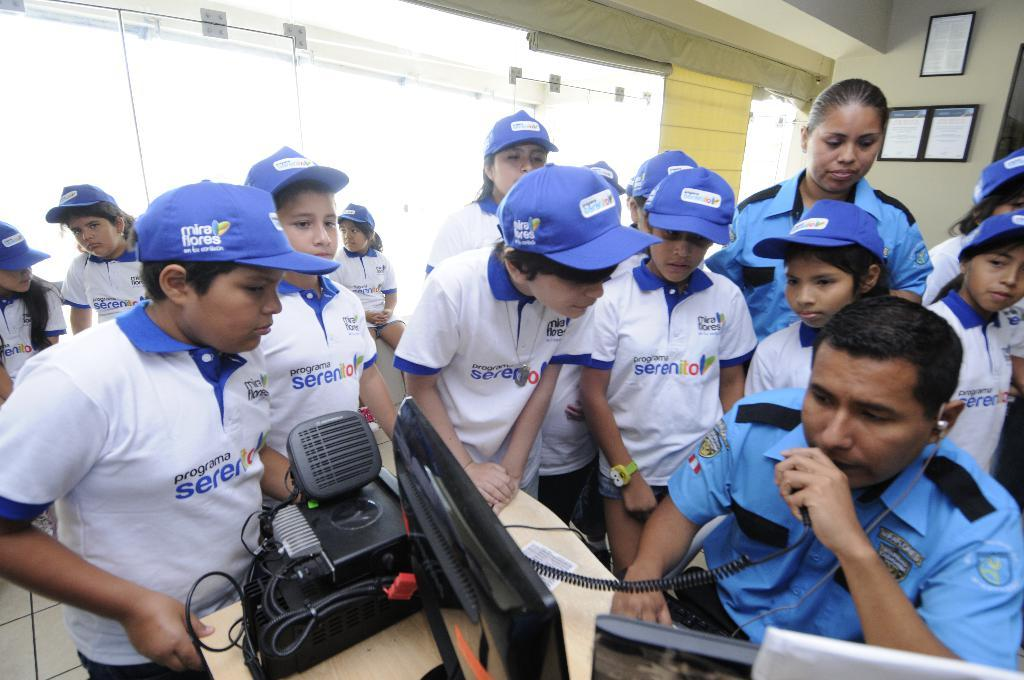<image>
Offer a succinct explanation of the picture presented. officer talking on radio while children wearing blue miraflores caps stand around him 